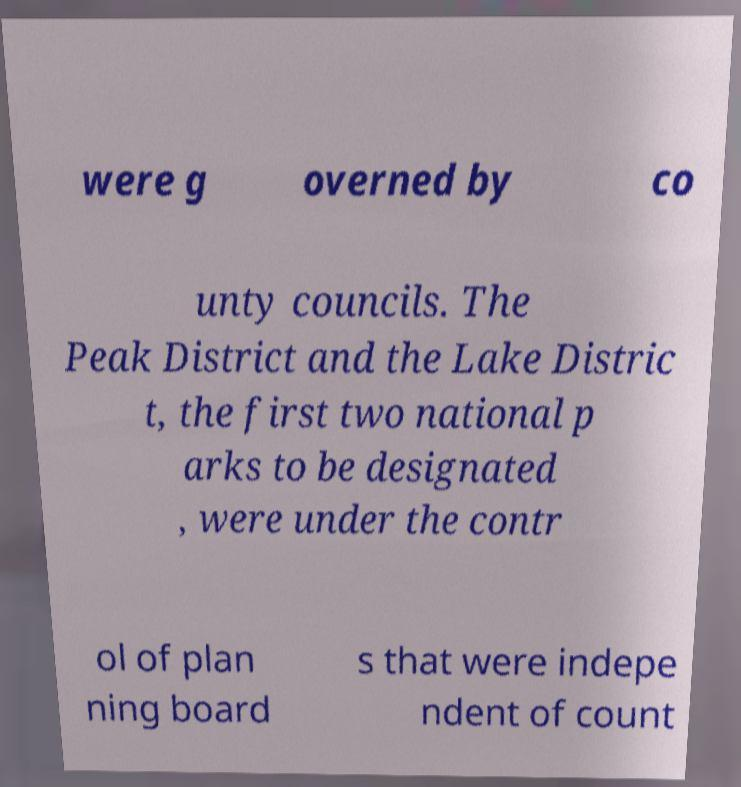Could you assist in decoding the text presented in this image and type it out clearly? were g overned by co unty councils. The Peak District and the Lake Distric t, the first two national p arks to be designated , were under the contr ol of plan ning board s that were indepe ndent of count 